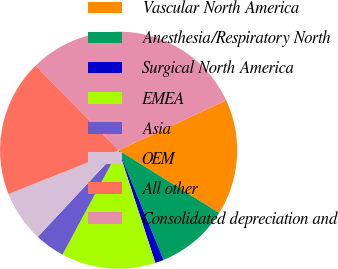Convert chart to OTSL. <chart><loc_0><loc_0><loc_500><loc_500><pie_chart><fcel>Vascular North America<fcel>Anesthesia/Respiratory North<fcel>Surgical North America<fcel>EMEA<fcel>Asia<fcel>OEM<fcel>All other<fcel>Consolidated depreciation and<nl><fcel>15.79%<fcel>9.94%<fcel>1.17%<fcel>12.87%<fcel>4.09%<fcel>7.02%<fcel>18.71%<fcel>30.41%<nl></chart> 